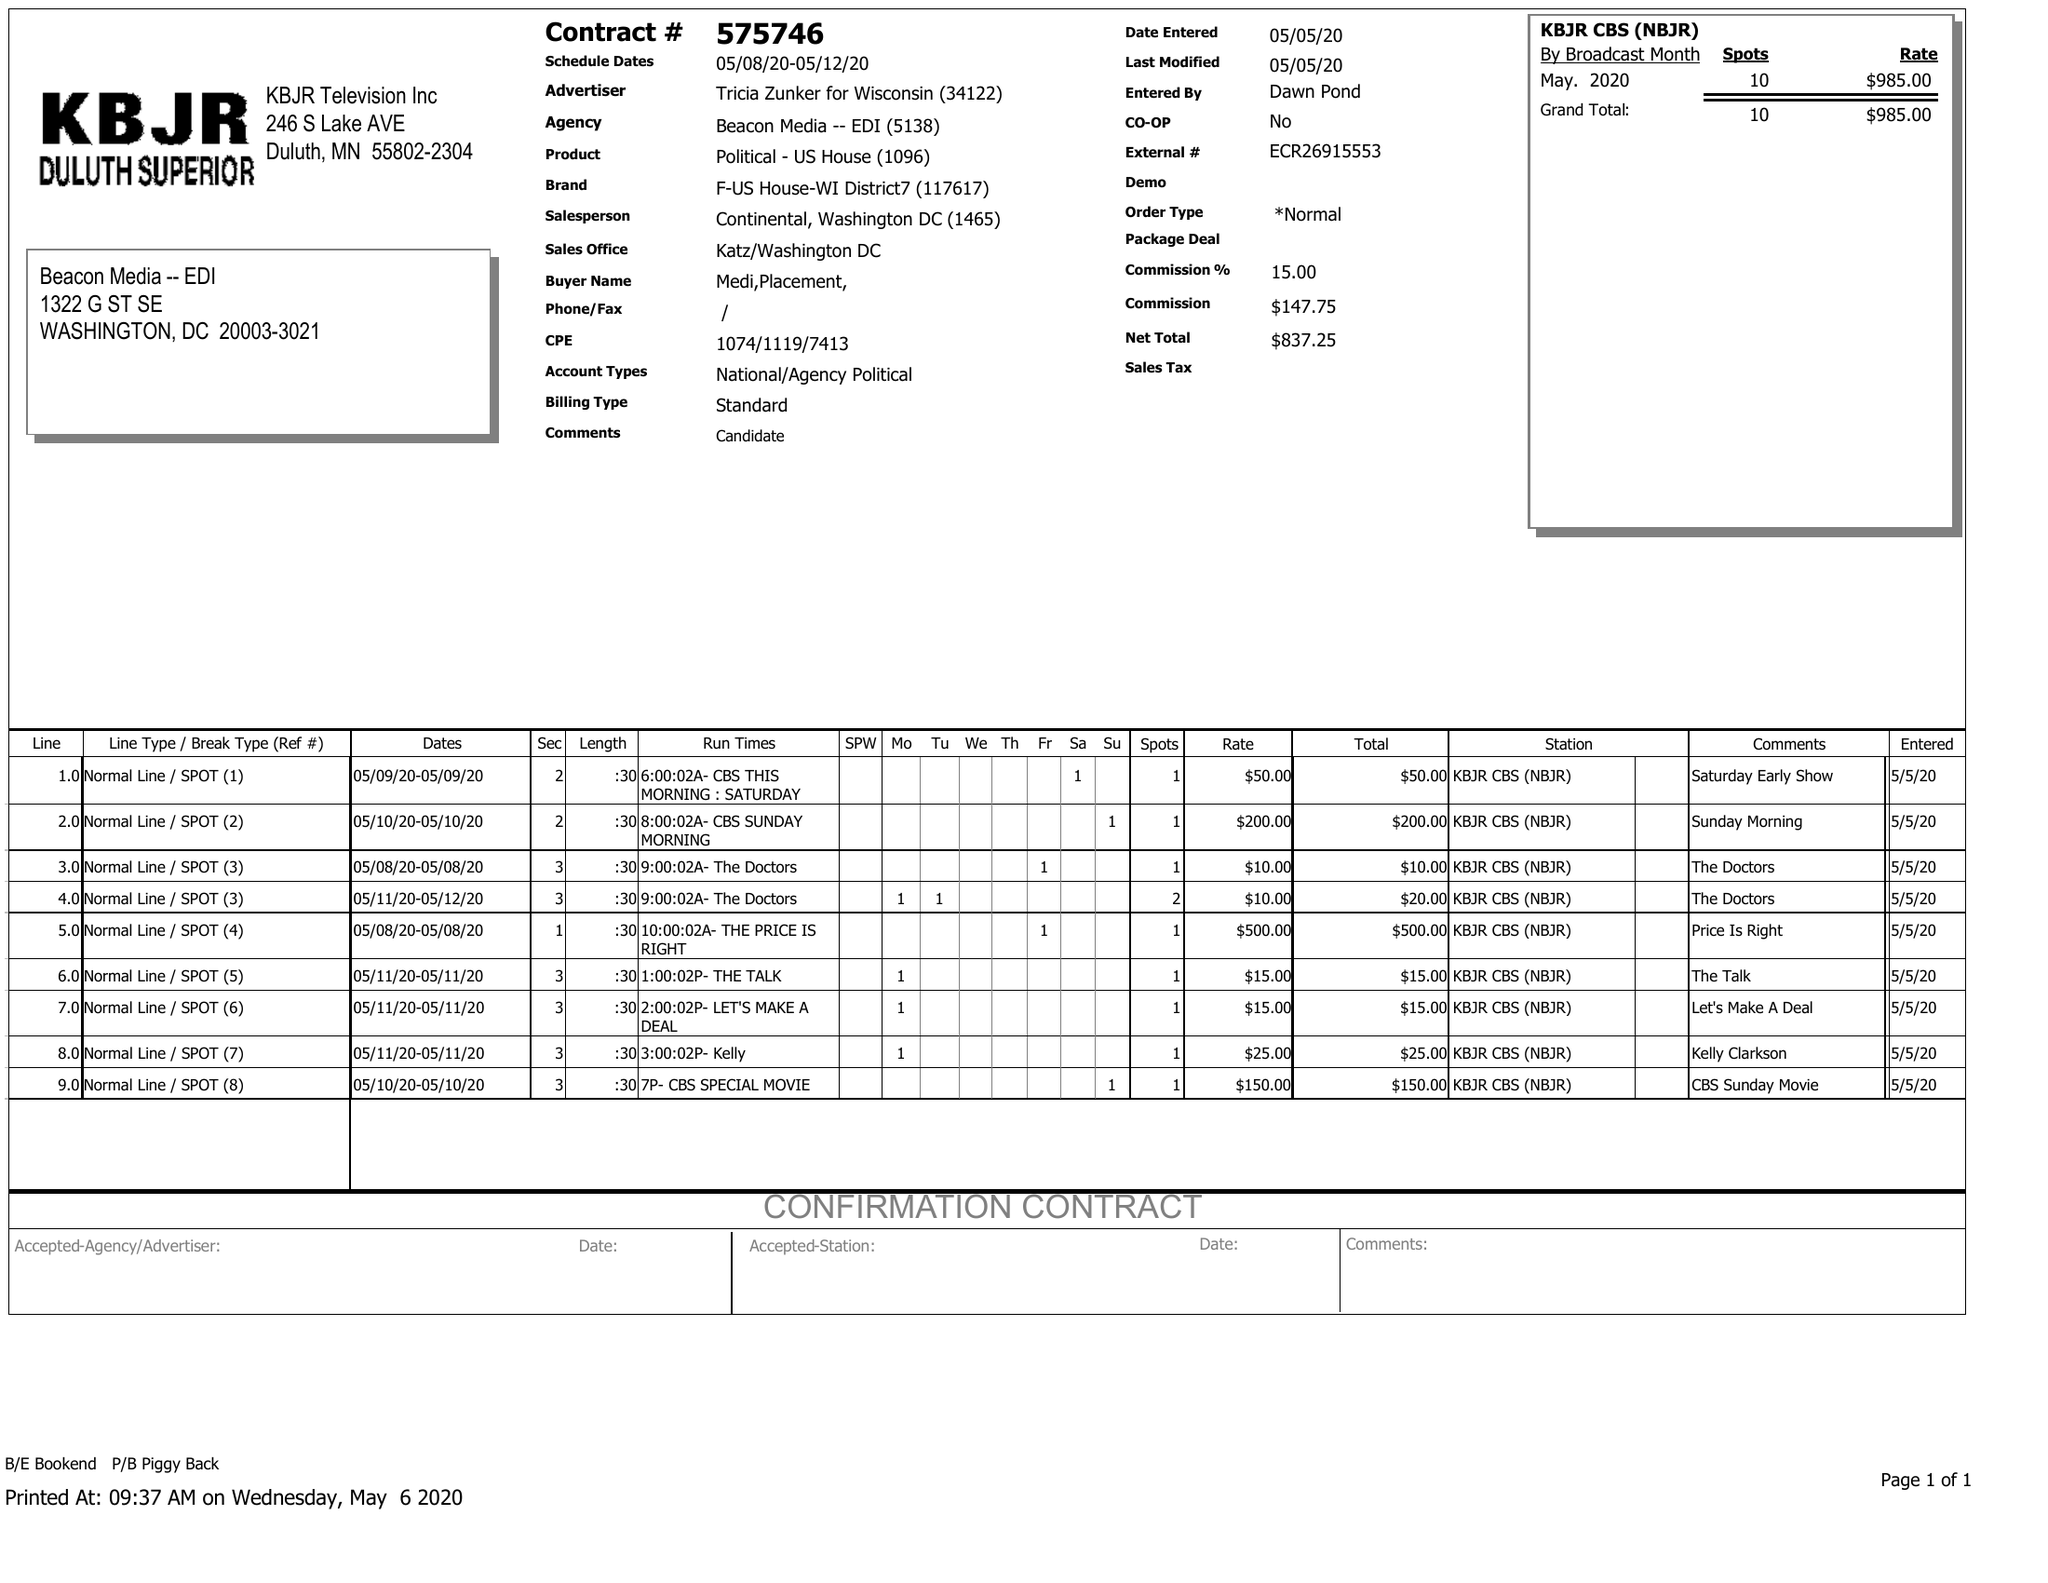What is the value for the gross_amount?
Answer the question using a single word or phrase. 985.00 